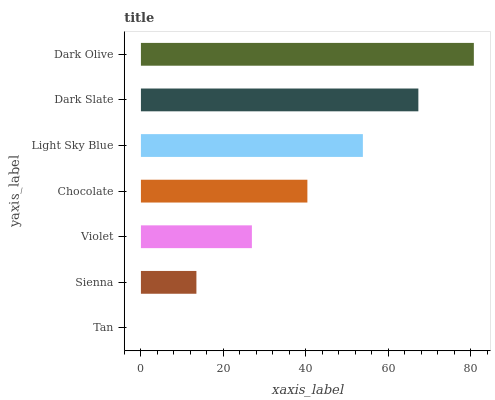Is Tan the minimum?
Answer yes or no. Yes. Is Dark Olive the maximum?
Answer yes or no. Yes. Is Sienna the minimum?
Answer yes or no. No. Is Sienna the maximum?
Answer yes or no. No. Is Sienna greater than Tan?
Answer yes or no. Yes. Is Tan less than Sienna?
Answer yes or no. Yes. Is Tan greater than Sienna?
Answer yes or no. No. Is Sienna less than Tan?
Answer yes or no. No. Is Chocolate the high median?
Answer yes or no. Yes. Is Chocolate the low median?
Answer yes or no. Yes. Is Tan the high median?
Answer yes or no. No. Is Tan the low median?
Answer yes or no. No. 